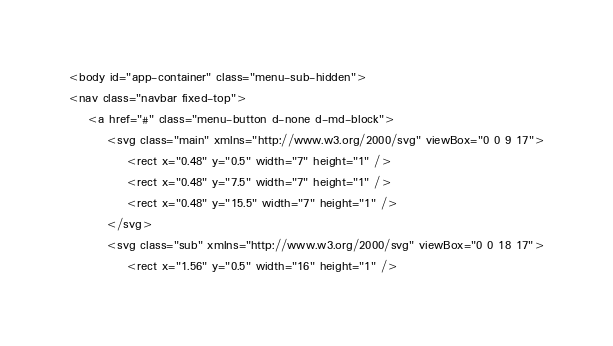<code> <loc_0><loc_0><loc_500><loc_500><_PHP_><body id="app-container" class="menu-sub-hidden">
<nav class="navbar fixed-top">
    <a href="#" class="menu-button d-none d-md-block">
        <svg class="main" xmlns="http://www.w3.org/2000/svg" viewBox="0 0 9 17">
            <rect x="0.48" y="0.5" width="7" height="1" />
            <rect x="0.48" y="7.5" width="7" height="1" />
            <rect x="0.48" y="15.5" width="7" height="1" />
        </svg>
        <svg class="sub" xmlns="http://www.w3.org/2000/svg" viewBox="0 0 18 17">
            <rect x="1.56" y="0.5" width="16" height="1" /></code> 